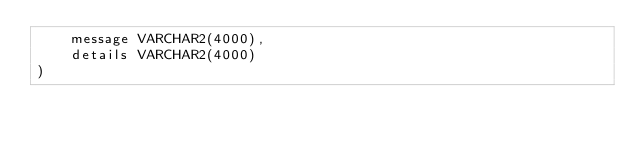Convert code to text. <code><loc_0><loc_0><loc_500><loc_500><_SQL_>    message VARCHAR2(4000),
    details VARCHAR2(4000)
)
</code> 